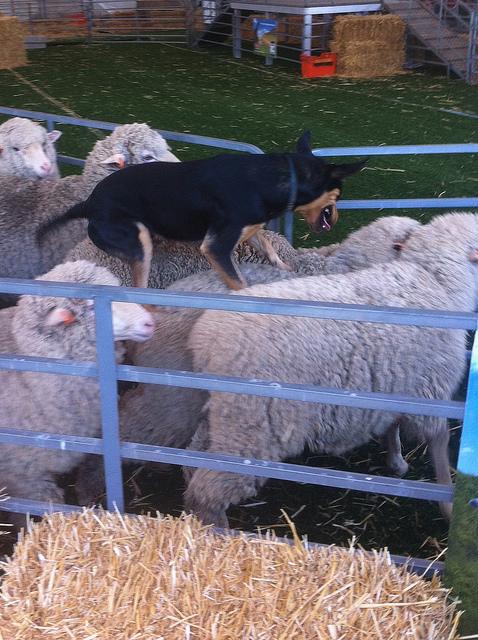What is the dog doing?
Write a very short answer. Standing on sheep. Is there any hay in the picture?
Quick response, please. Yes. Why are the sheep in a cage?
Write a very short answer. For evening. 